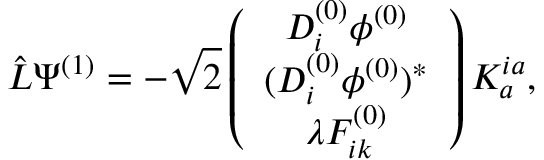Convert formula to latex. <formula><loc_0><loc_0><loc_500><loc_500>\hat { L } \Psi ^ { ( 1 ) } = - \sqrt { 2 } \left ( \begin{array} { c } { { D _ { i } ^ { ( 0 ) } \phi ^ { ( 0 ) } } } \\ { { ( D _ { i } ^ { ( 0 ) } \phi ^ { ( 0 ) } ) ^ { \ast } } } \\ { { \lambda F _ { i k } ^ { ( 0 ) } } } \end{array} \right ) K _ { a } ^ { i a } ,</formula> 